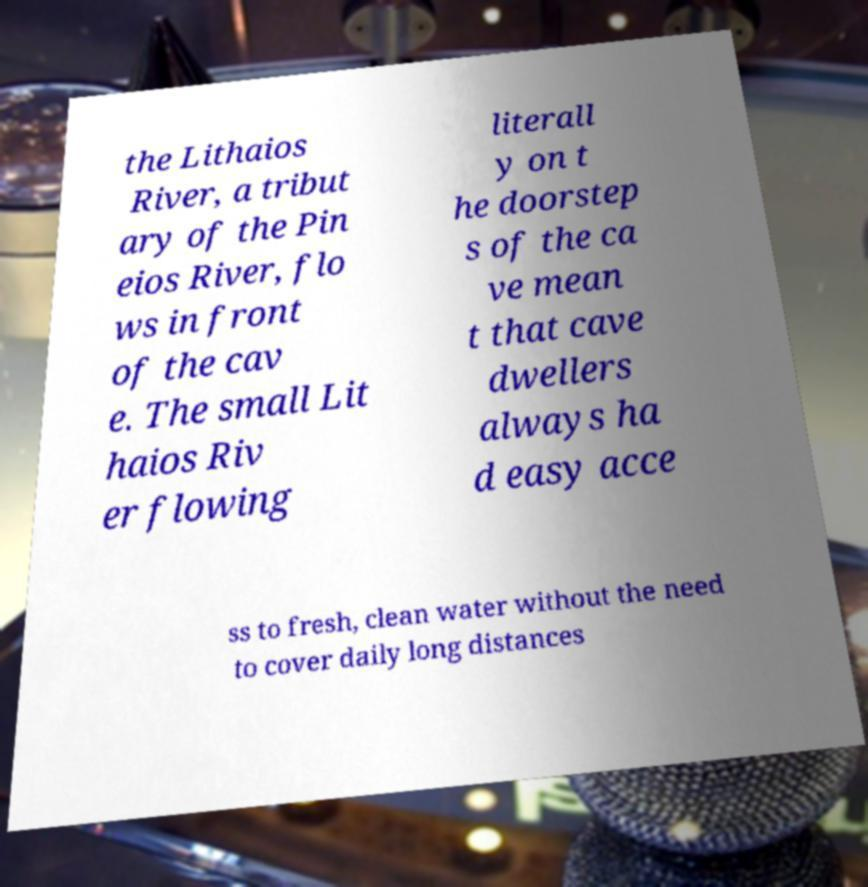Can you read and provide the text displayed in the image?This photo seems to have some interesting text. Can you extract and type it out for me? the Lithaios River, a tribut ary of the Pin eios River, flo ws in front of the cav e. The small Lit haios Riv er flowing literall y on t he doorstep s of the ca ve mean t that cave dwellers always ha d easy acce ss to fresh, clean water without the need to cover daily long distances 